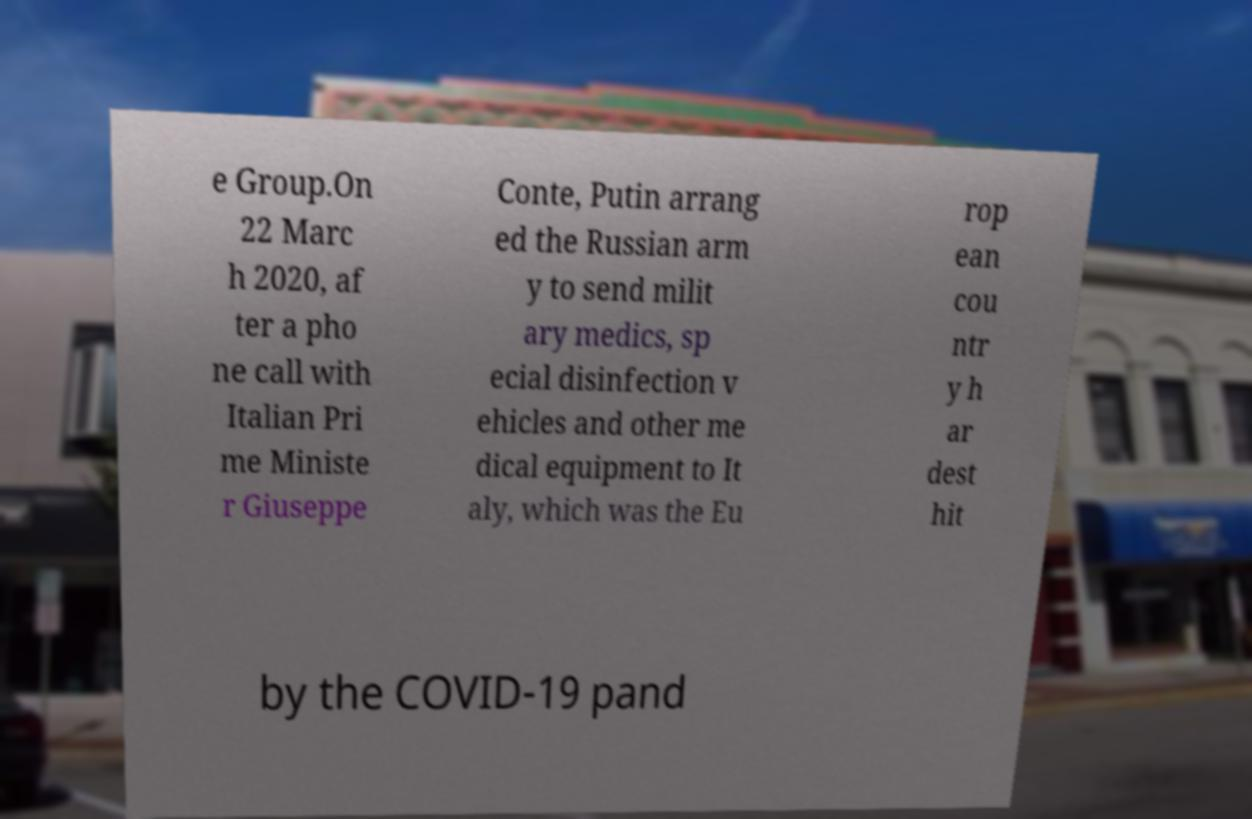Could you assist in decoding the text presented in this image and type it out clearly? e Group.On 22 Marc h 2020, af ter a pho ne call with Italian Pri me Ministe r Giuseppe Conte, Putin arrang ed the Russian arm y to send milit ary medics, sp ecial disinfection v ehicles and other me dical equipment to It aly, which was the Eu rop ean cou ntr y h ar dest hit by the COVID-19 pand 